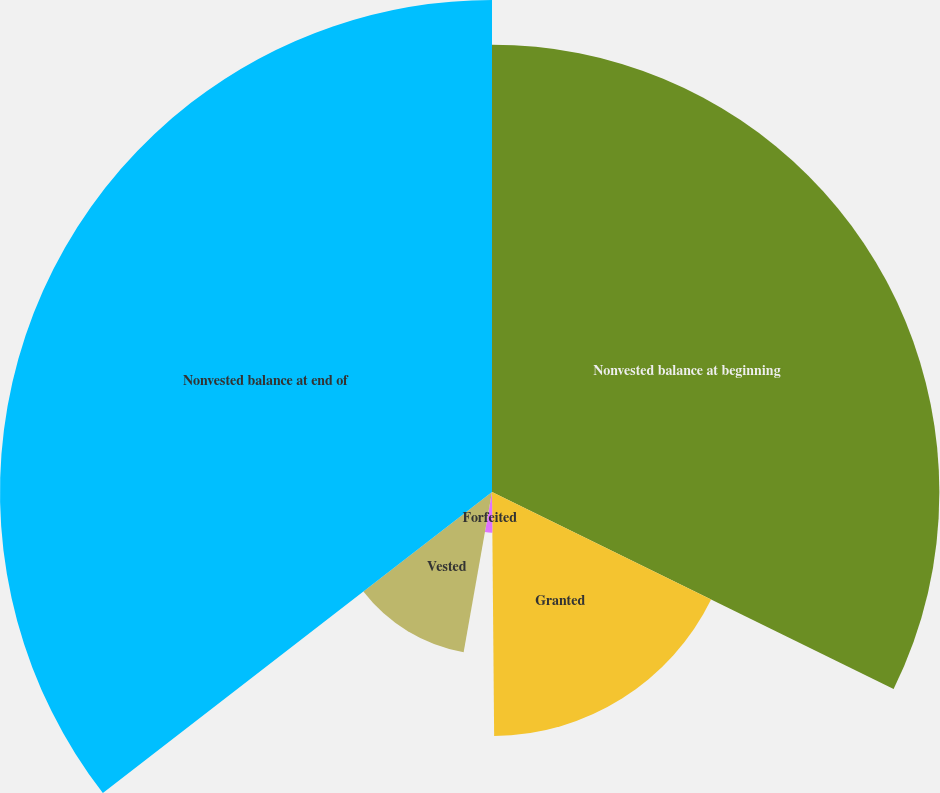<chart> <loc_0><loc_0><loc_500><loc_500><pie_chart><fcel>Nonvested balance at beginning<fcel>Granted<fcel>Forfeited<fcel>Vested<fcel>Nonvested balance at end of<nl><fcel>32.26%<fcel>17.6%<fcel>2.93%<fcel>11.73%<fcel>35.48%<nl></chart> 